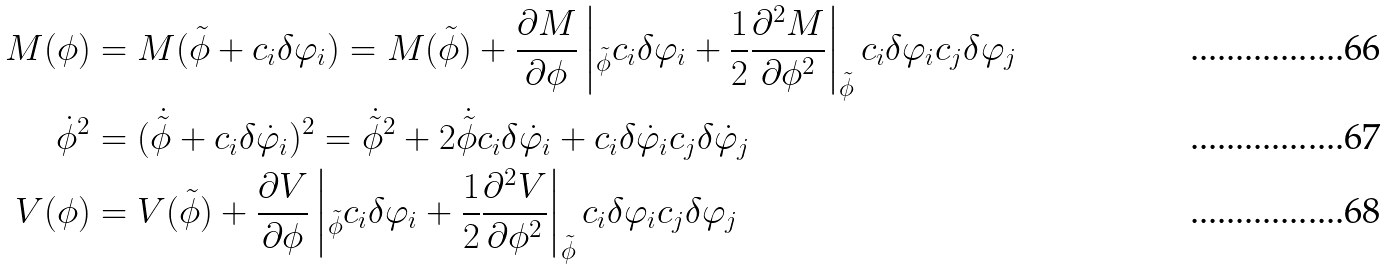<formula> <loc_0><loc_0><loc_500><loc_500>M ( \phi ) & = M ( \tilde { \phi } + c _ { i } \delta \varphi _ { i } ) = M ( \tilde { \phi } ) + \frac { \partial M } { \partial \phi } \left | _ { \tilde { \phi } } c _ { i } \delta \varphi _ { i } + \frac { 1 } { 2 } \frac { \partial ^ { 2 } M } { \partial \phi ^ { 2 } } \right | _ { \tilde { \phi } } c _ { i } \delta \varphi _ { i } c _ { j } \delta \varphi _ { j } \\ \dot { \phi } ^ { 2 } & = ( \dot { \tilde { \phi } } + c _ { i } \delta \dot { \varphi } _ { i } ) ^ { 2 } = \dot { \tilde { \phi } } ^ { 2 } + 2 \dot { \tilde { \phi } } c _ { i } \delta \dot { \varphi } _ { i } + c _ { i } \delta \dot { \varphi } _ { i } c _ { j } \delta \dot { \varphi } _ { j } \\ V ( \phi ) & = V ( \tilde { \phi } ) + \frac { \partial V } { \partial \phi } \left | _ { \tilde { \phi } } c _ { i } \delta \varphi _ { i } + \frac { 1 } { 2 } \frac { \partial ^ { 2 } V } { \partial \phi ^ { 2 } } \right | _ { \tilde { \phi } } c _ { i } \delta \varphi _ { i } c _ { j } \delta \varphi _ { j }</formula> 